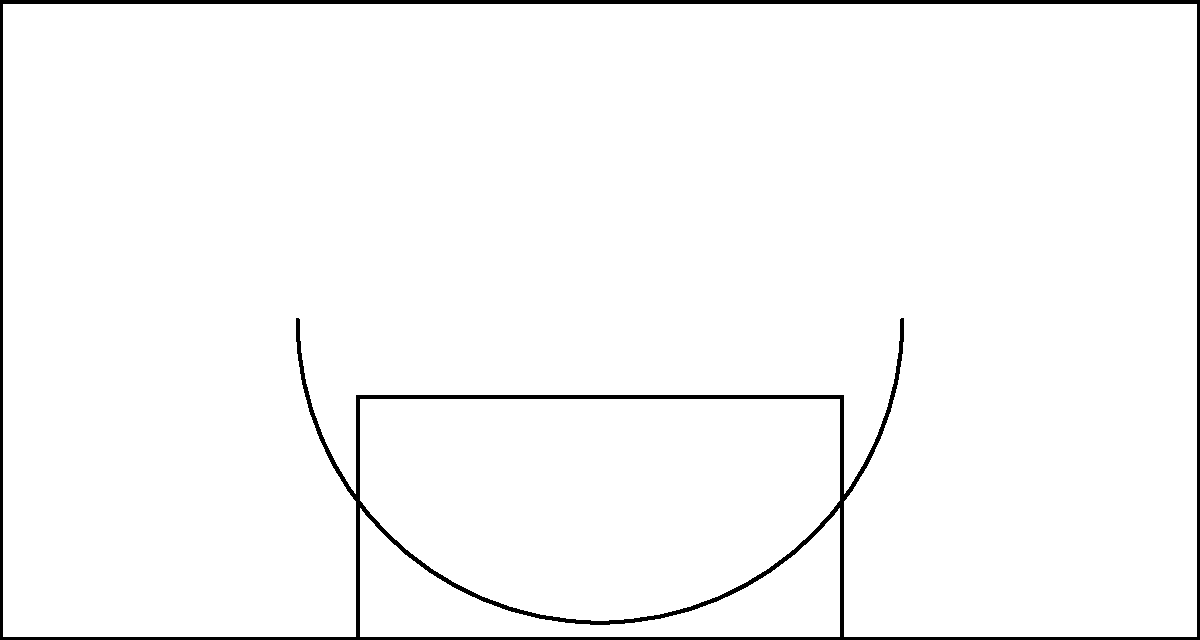Based on the heatmap of player shot locations on a basketball court, which area shows the highest concentration of shots, and what might this suggest about the player's shooting tendencies? To interpret this heatmap and answer the question, let's follow these steps:

1. Understand the heatmap: The colors range from light (low concentration) to dark red (high concentration), indicating the frequency of shots taken from different locations.

2. Identify the court areas: The diagram shows half of a basketball court, including the three-point line and the key (painted area).

3. Locate the darkest red area: The darkest red circle is at the center of the bottom row, just inside the three-point line.

4. Interpret the location: This area corresponds to the top of the key, also known as the "elbow" or high post area.

5. Consider player tendencies: A high concentration of shots from this area suggests that the player:
   a) Is comfortable shooting mid-range jump shots
   b) May often receive passes or create shots from this position
   c) Might be a power forward or center who operates effectively from the high post

6. Compare to other areas: Note that the concentration decreases as we move towards the basket or out to the three-point line, indicating fewer shots from these areas.

7. Strategic implications: This shooting pattern could indicate that defenders should focus on contesting shots from the high post area when guarding this player.
Answer: Top of the key (high post); player likely specializes in mid-range jump shots. 